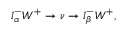<formula> <loc_0><loc_0><loc_500><loc_500>l _ { \alpha } ^ { - } W ^ { + } \rightarrow \nu \rightarrow l _ { \beta } ^ { - } W ^ { + } ,</formula> 